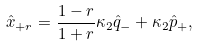Convert formula to latex. <formula><loc_0><loc_0><loc_500><loc_500>\hat { x } _ { + r } = \frac { 1 - r } { 1 + r } \kappa _ { 2 } \hat { q } _ { - } + \kappa _ { 2 } \hat { p } _ { + } ,</formula> 